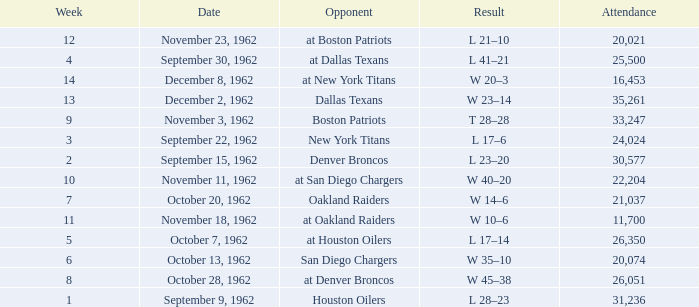What week was the attendance smaller than 22,204 on December 8, 1962? 14.0. 